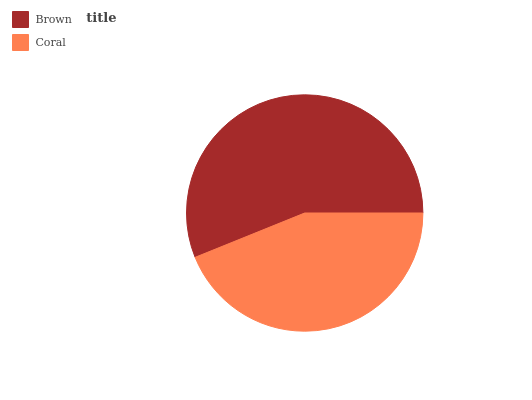Is Coral the minimum?
Answer yes or no. Yes. Is Brown the maximum?
Answer yes or no. Yes. Is Coral the maximum?
Answer yes or no. No. Is Brown greater than Coral?
Answer yes or no. Yes. Is Coral less than Brown?
Answer yes or no. Yes. Is Coral greater than Brown?
Answer yes or no. No. Is Brown less than Coral?
Answer yes or no. No. Is Brown the high median?
Answer yes or no. Yes. Is Coral the low median?
Answer yes or no. Yes. Is Coral the high median?
Answer yes or no. No. Is Brown the low median?
Answer yes or no. No. 